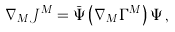<formula> <loc_0><loc_0><loc_500><loc_500>\nabla _ { M } J ^ { M } = \bar { \Psi } \left ( \nabla _ { M } \Gamma ^ { M } \right ) \Psi \, ,</formula> 